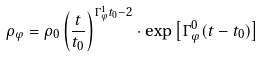<formula> <loc_0><loc_0><loc_500><loc_500>\rho _ { \varphi } = \rho _ { 0 } \left ( \frac { t } { t _ { 0 } } \right ) ^ { \Gamma _ { \varphi } ^ { 1 } t _ { 0 } - 2 } \cdot \exp \left [ \Gamma _ { \varphi } ^ { 0 } ( t - t _ { 0 } ) \right ]</formula> 